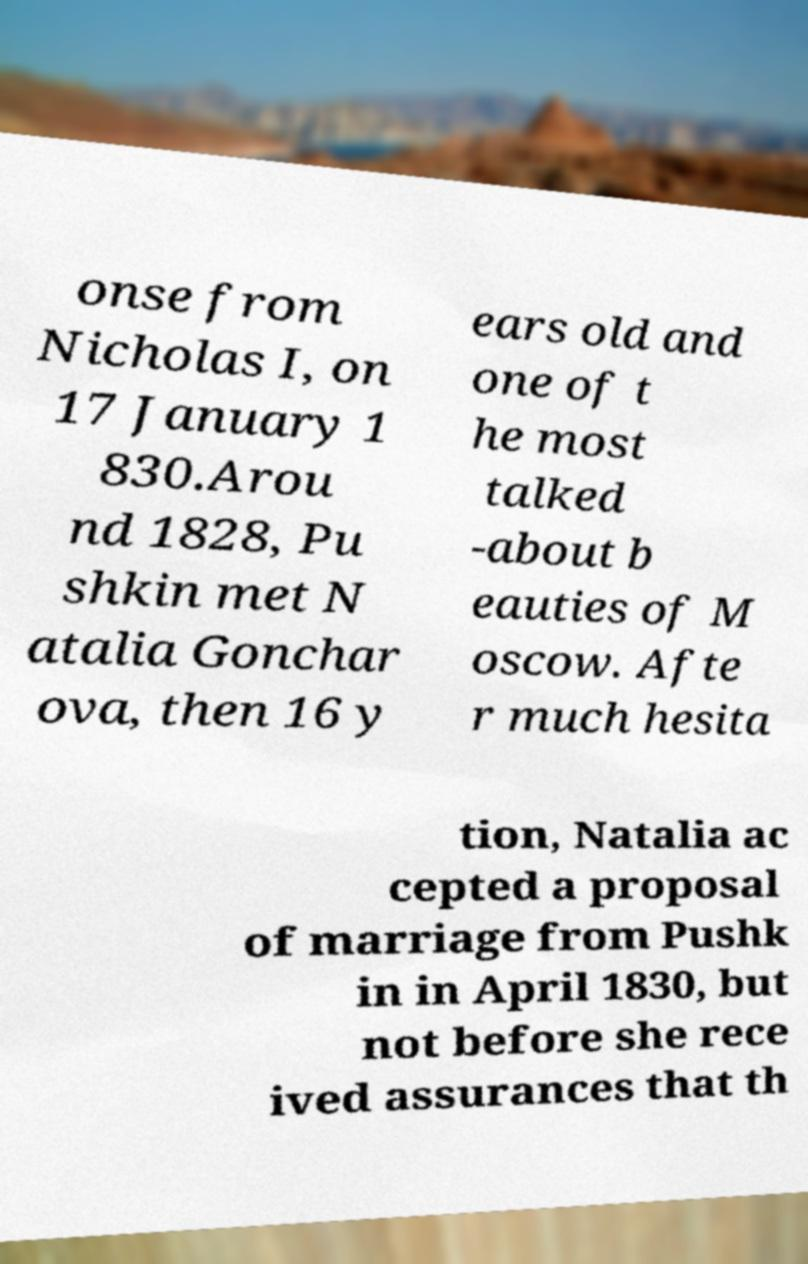For documentation purposes, I need the text within this image transcribed. Could you provide that? onse from Nicholas I, on 17 January 1 830.Arou nd 1828, Pu shkin met N atalia Gonchar ova, then 16 y ears old and one of t he most talked -about b eauties of M oscow. Afte r much hesita tion, Natalia ac cepted a proposal of marriage from Pushk in in April 1830, but not before she rece ived assurances that th 